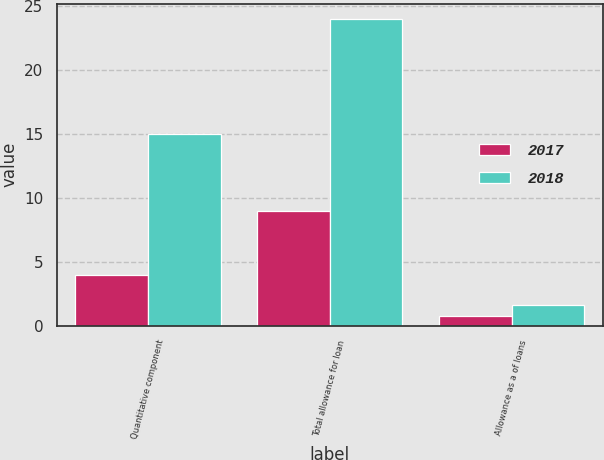<chart> <loc_0><loc_0><loc_500><loc_500><stacked_bar_chart><ecel><fcel>Quantitative component<fcel>Total allowance for loan<fcel>Allowance as a of loans<nl><fcel>2017<fcel>4<fcel>9<fcel>0.8<nl><fcel>2018<fcel>15<fcel>24<fcel>1.6<nl></chart> 